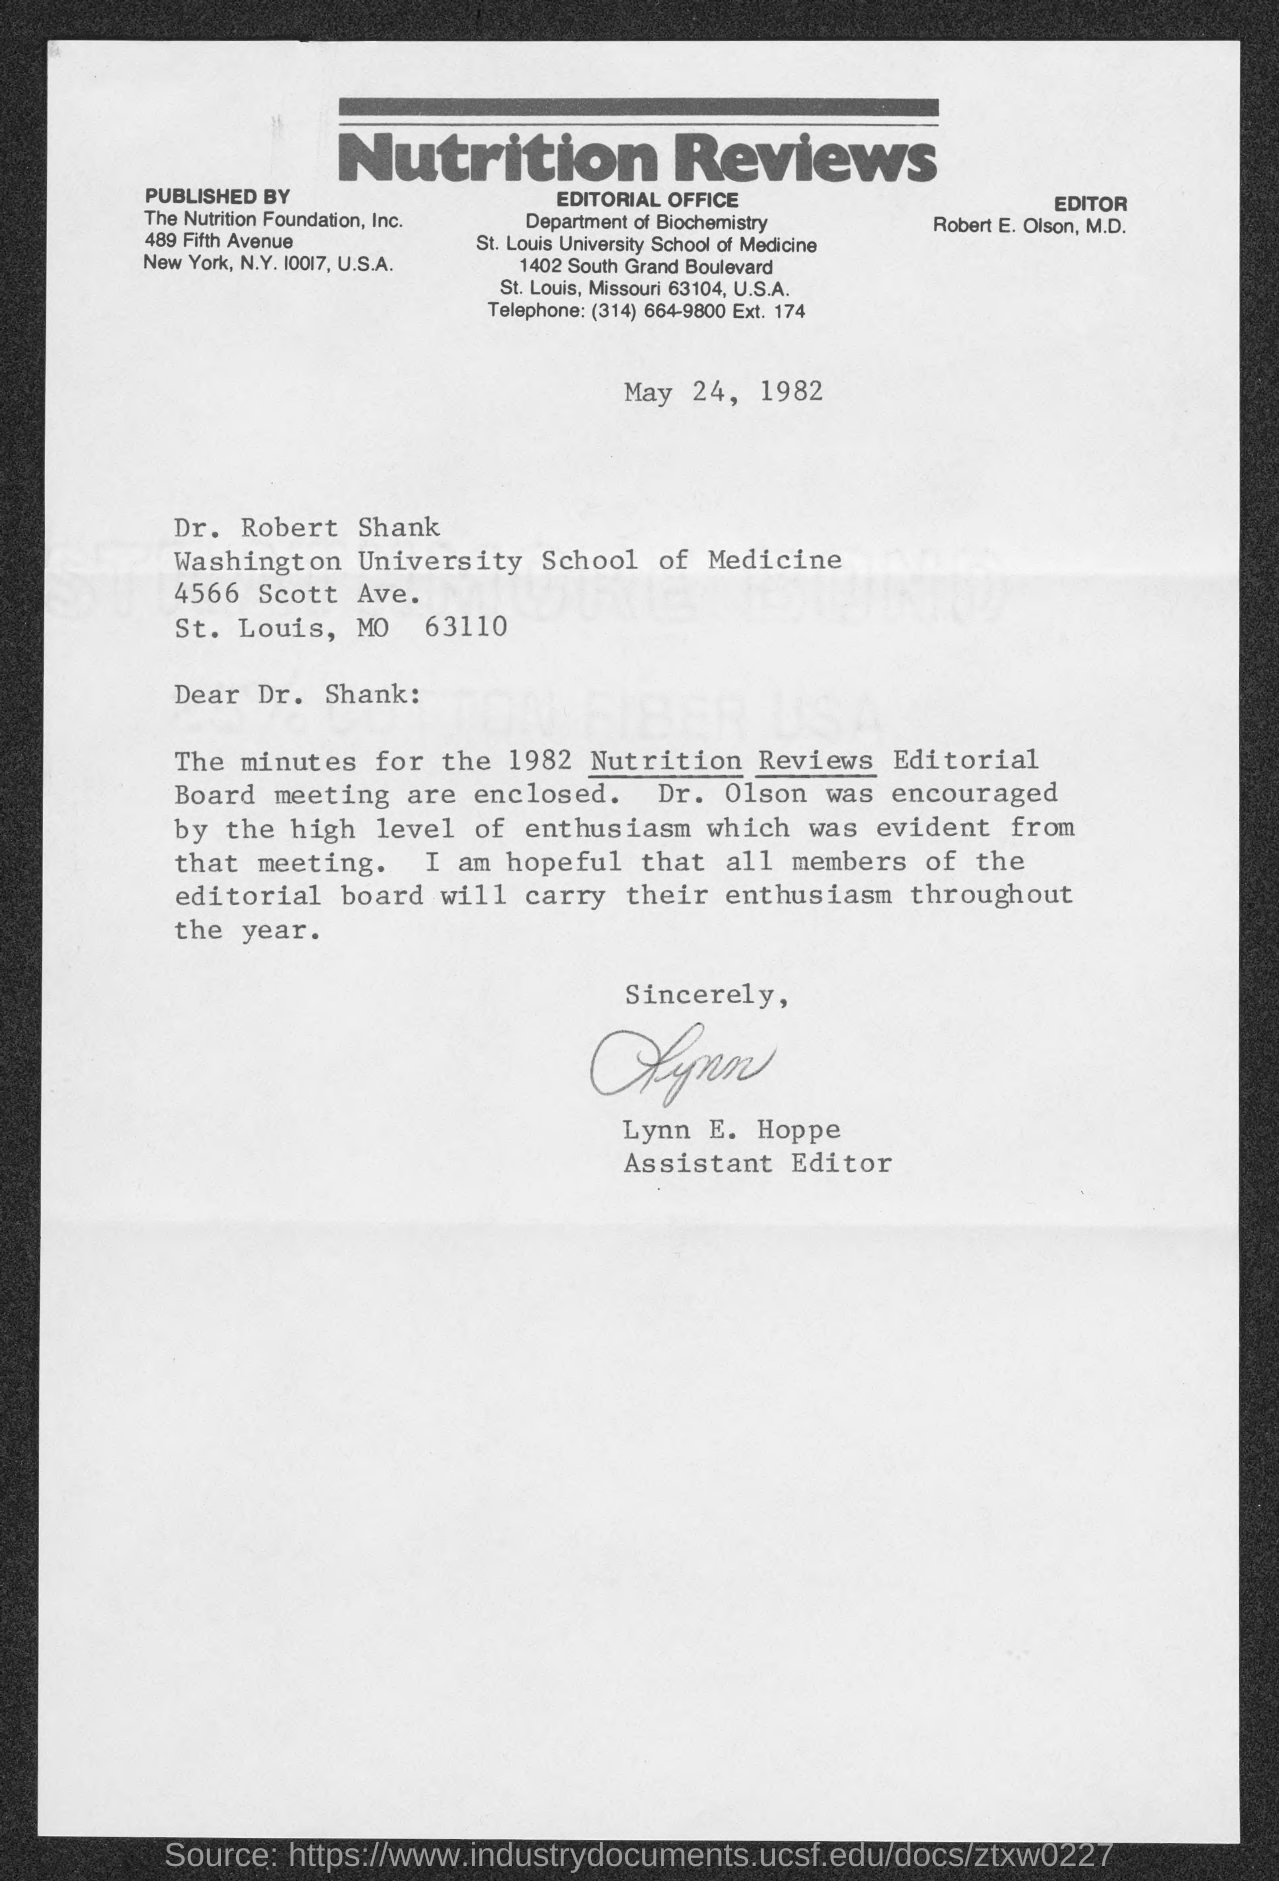Draw attention to some important aspects in this diagram. The date mentioned in the letter is May 24, 1982. The person who wrote this letter is Lynn E. Hoppe. 